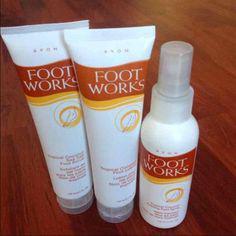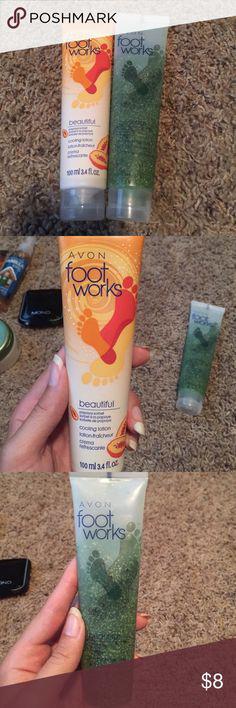The first image is the image on the left, the second image is the image on the right. Considering the images on both sides, is "An image shows a product with orange-and-white tube-type container standing upright on its cap." valid? Answer yes or no. Yes. The first image is the image on the left, the second image is the image on the right. Assess this claim about the two images: "The products are of the FootWorks brand.". Correct or not? Answer yes or no. Yes. 